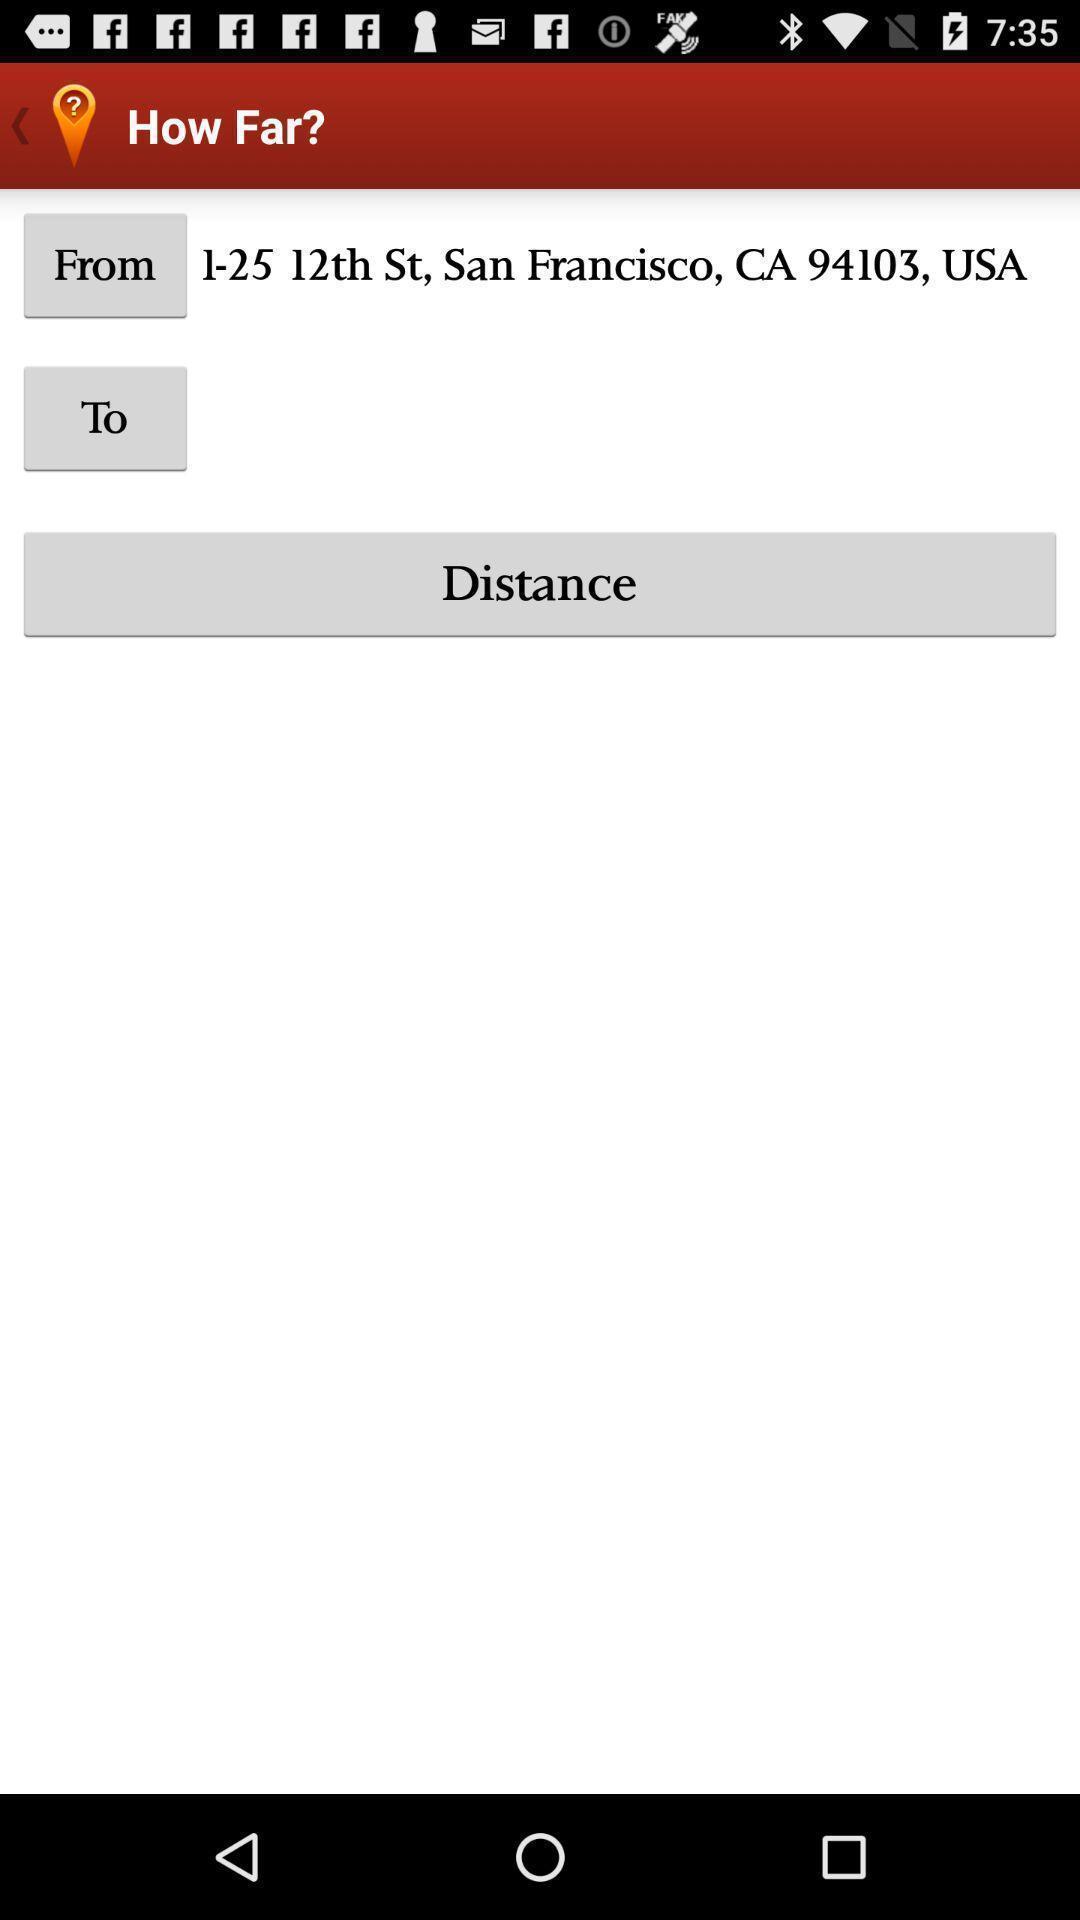Give me a narrative description of this picture. Page to calculate the distance between to places. 